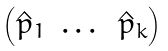<formula> <loc_0><loc_0><loc_500><loc_500>\begin{pmatrix} \hat { p } _ { 1 } & \dots & \hat { p } _ { k } \end{pmatrix}</formula> 